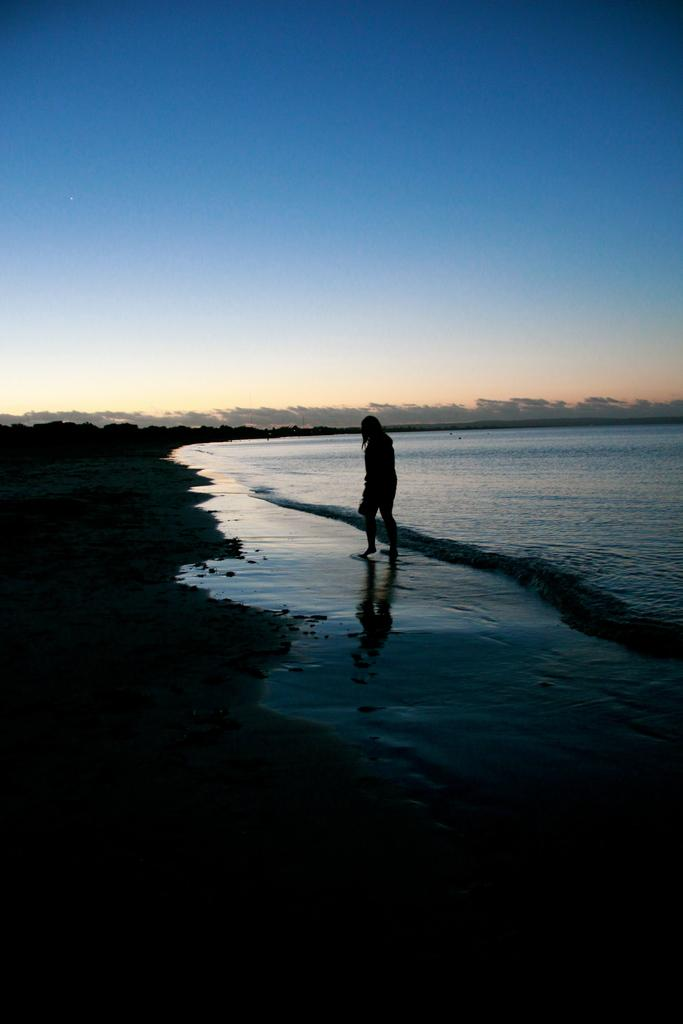Who or what is present in the image? There is a person in the image. What is the person doing in the image? The person is walking on a path. What natural element can be seen in the image? Water is visible in the image. What else can be seen in the sky in the image? The sky is visible in the image. What type of rice is being cooked by the person in the image? There is no rice present in the image, and the person is walking on a path, not cooking. 